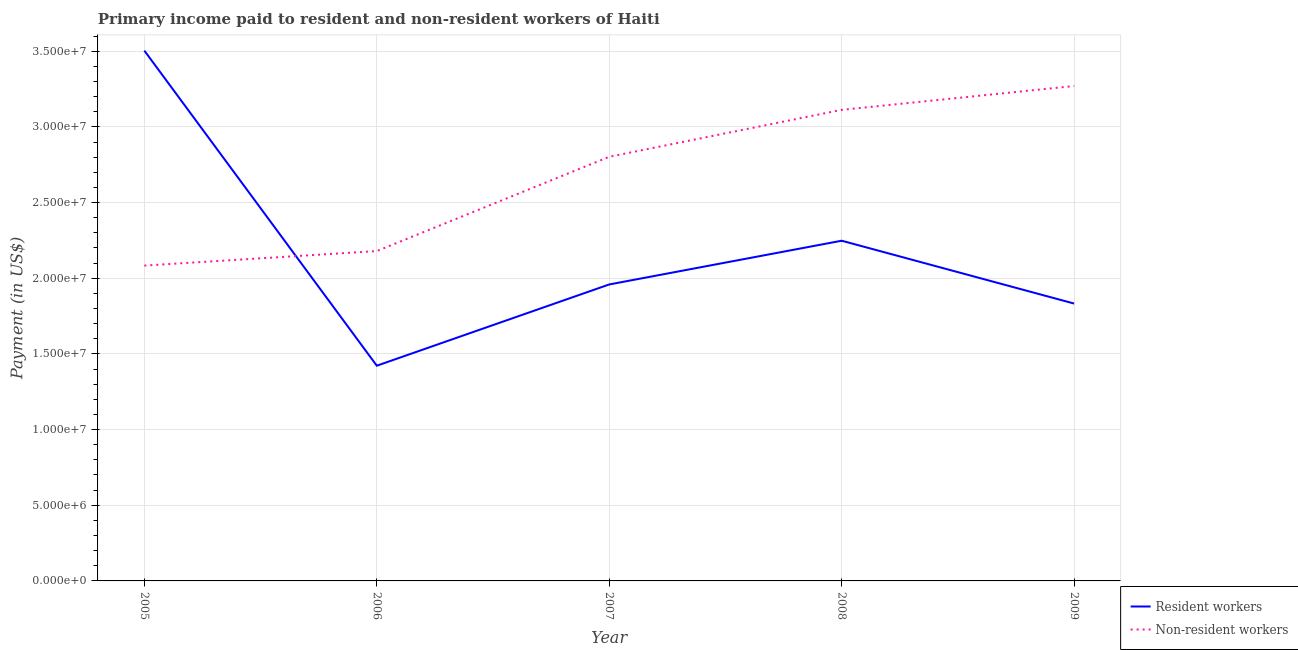Is the number of lines equal to the number of legend labels?
Give a very brief answer. Yes. What is the payment made to resident workers in 2006?
Make the answer very short. 1.42e+07. Across all years, what is the maximum payment made to non-resident workers?
Provide a short and direct response. 3.27e+07. Across all years, what is the minimum payment made to non-resident workers?
Your response must be concise. 2.08e+07. In which year was the payment made to non-resident workers maximum?
Provide a short and direct response. 2009. In which year was the payment made to resident workers minimum?
Make the answer very short. 2006. What is the total payment made to resident workers in the graph?
Make the answer very short. 1.10e+08. What is the difference between the payment made to resident workers in 2007 and that in 2009?
Provide a succinct answer. 1.26e+06. What is the difference between the payment made to resident workers in 2007 and the payment made to non-resident workers in 2006?
Offer a terse response. -2.21e+06. What is the average payment made to non-resident workers per year?
Make the answer very short. 2.69e+07. In the year 2008, what is the difference between the payment made to resident workers and payment made to non-resident workers?
Offer a very short reply. -8.65e+06. In how many years, is the payment made to non-resident workers greater than 24000000 US$?
Provide a short and direct response. 3. What is the ratio of the payment made to resident workers in 2005 to that in 2006?
Provide a succinct answer. 2.46. What is the difference between the highest and the second highest payment made to resident workers?
Make the answer very short. 1.26e+07. What is the difference between the highest and the lowest payment made to resident workers?
Give a very brief answer. 2.08e+07. Is the sum of the payment made to resident workers in 2005 and 2007 greater than the maximum payment made to non-resident workers across all years?
Your answer should be very brief. Yes. Does the payment made to resident workers monotonically increase over the years?
Provide a succinct answer. No. Is the payment made to non-resident workers strictly greater than the payment made to resident workers over the years?
Keep it short and to the point. No. Is the payment made to resident workers strictly less than the payment made to non-resident workers over the years?
Provide a short and direct response. No. What is the difference between two consecutive major ticks on the Y-axis?
Give a very brief answer. 5.00e+06. Are the values on the major ticks of Y-axis written in scientific E-notation?
Your response must be concise. Yes. How many legend labels are there?
Provide a succinct answer. 2. What is the title of the graph?
Make the answer very short. Primary income paid to resident and non-resident workers of Haiti. What is the label or title of the X-axis?
Ensure brevity in your answer.  Year. What is the label or title of the Y-axis?
Make the answer very short. Payment (in US$). What is the Payment (in US$) of Resident workers in 2005?
Your response must be concise. 3.50e+07. What is the Payment (in US$) of Non-resident workers in 2005?
Offer a very short reply. 2.08e+07. What is the Payment (in US$) of Resident workers in 2006?
Your response must be concise. 1.42e+07. What is the Payment (in US$) in Non-resident workers in 2006?
Ensure brevity in your answer.  2.18e+07. What is the Payment (in US$) in Resident workers in 2007?
Your answer should be very brief. 1.96e+07. What is the Payment (in US$) in Non-resident workers in 2007?
Your answer should be very brief. 2.80e+07. What is the Payment (in US$) in Resident workers in 2008?
Your answer should be compact. 2.25e+07. What is the Payment (in US$) in Non-resident workers in 2008?
Keep it short and to the point. 3.11e+07. What is the Payment (in US$) in Resident workers in 2009?
Your answer should be compact. 1.83e+07. What is the Payment (in US$) of Non-resident workers in 2009?
Provide a short and direct response. 3.27e+07. Across all years, what is the maximum Payment (in US$) in Resident workers?
Offer a terse response. 3.50e+07. Across all years, what is the maximum Payment (in US$) in Non-resident workers?
Your response must be concise. 3.27e+07. Across all years, what is the minimum Payment (in US$) in Resident workers?
Offer a very short reply. 1.42e+07. Across all years, what is the minimum Payment (in US$) of Non-resident workers?
Offer a very short reply. 2.08e+07. What is the total Payment (in US$) of Resident workers in the graph?
Provide a short and direct response. 1.10e+08. What is the total Payment (in US$) in Non-resident workers in the graph?
Provide a succinct answer. 1.34e+08. What is the difference between the Payment (in US$) in Resident workers in 2005 and that in 2006?
Provide a short and direct response. 2.08e+07. What is the difference between the Payment (in US$) of Non-resident workers in 2005 and that in 2006?
Provide a succinct answer. -9.59e+05. What is the difference between the Payment (in US$) in Resident workers in 2005 and that in 2007?
Provide a short and direct response. 1.54e+07. What is the difference between the Payment (in US$) in Non-resident workers in 2005 and that in 2007?
Offer a very short reply. -7.19e+06. What is the difference between the Payment (in US$) of Resident workers in 2005 and that in 2008?
Offer a very short reply. 1.26e+07. What is the difference between the Payment (in US$) in Non-resident workers in 2005 and that in 2008?
Your response must be concise. -1.03e+07. What is the difference between the Payment (in US$) of Resident workers in 2005 and that in 2009?
Offer a very short reply. 1.67e+07. What is the difference between the Payment (in US$) of Non-resident workers in 2005 and that in 2009?
Provide a succinct answer. -1.19e+07. What is the difference between the Payment (in US$) in Resident workers in 2006 and that in 2007?
Give a very brief answer. -5.37e+06. What is the difference between the Payment (in US$) in Non-resident workers in 2006 and that in 2007?
Ensure brevity in your answer.  -6.23e+06. What is the difference between the Payment (in US$) in Resident workers in 2006 and that in 2008?
Ensure brevity in your answer.  -8.26e+06. What is the difference between the Payment (in US$) of Non-resident workers in 2006 and that in 2008?
Keep it short and to the point. -9.33e+06. What is the difference between the Payment (in US$) of Resident workers in 2006 and that in 2009?
Offer a terse response. -4.11e+06. What is the difference between the Payment (in US$) of Non-resident workers in 2006 and that in 2009?
Your answer should be compact. -1.09e+07. What is the difference between the Payment (in US$) of Resident workers in 2007 and that in 2008?
Keep it short and to the point. -2.89e+06. What is the difference between the Payment (in US$) of Non-resident workers in 2007 and that in 2008?
Provide a short and direct response. -3.10e+06. What is the difference between the Payment (in US$) in Resident workers in 2007 and that in 2009?
Provide a short and direct response. 1.26e+06. What is the difference between the Payment (in US$) in Non-resident workers in 2007 and that in 2009?
Offer a very short reply. -4.68e+06. What is the difference between the Payment (in US$) of Resident workers in 2008 and that in 2009?
Your answer should be very brief. 4.15e+06. What is the difference between the Payment (in US$) of Non-resident workers in 2008 and that in 2009?
Provide a succinct answer. -1.58e+06. What is the difference between the Payment (in US$) of Resident workers in 2005 and the Payment (in US$) of Non-resident workers in 2006?
Provide a short and direct response. 1.32e+07. What is the difference between the Payment (in US$) in Resident workers in 2005 and the Payment (in US$) in Non-resident workers in 2007?
Make the answer very short. 7.01e+06. What is the difference between the Payment (in US$) of Resident workers in 2005 and the Payment (in US$) of Non-resident workers in 2008?
Provide a succinct answer. 3.91e+06. What is the difference between the Payment (in US$) in Resident workers in 2005 and the Payment (in US$) in Non-resident workers in 2009?
Give a very brief answer. 2.34e+06. What is the difference between the Payment (in US$) in Resident workers in 2006 and the Payment (in US$) in Non-resident workers in 2007?
Your answer should be very brief. -1.38e+07. What is the difference between the Payment (in US$) in Resident workers in 2006 and the Payment (in US$) in Non-resident workers in 2008?
Your response must be concise. -1.69e+07. What is the difference between the Payment (in US$) of Resident workers in 2006 and the Payment (in US$) of Non-resident workers in 2009?
Offer a terse response. -1.85e+07. What is the difference between the Payment (in US$) of Resident workers in 2007 and the Payment (in US$) of Non-resident workers in 2008?
Provide a succinct answer. -1.15e+07. What is the difference between the Payment (in US$) of Resident workers in 2007 and the Payment (in US$) of Non-resident workers in 2009?
Give a very brief answer. -1.31e+07. What is the difference between the Payment (in US$) in Resident workers in 2008 and the Payment (in US$) in Non-resident workers in 2009?
Provide a short and direct response. -1.02e+07. What is the average Payment (in US$) of Resident workers per year?
Offer a very short reply. 2.19e+07. What is the average Payment (in US$) in Non-resident workers per year?
Keep it short and to the point. 2.69e+07. In the year 2005, what is the difference between the Payment (in US$) in Resident workers and Payment (in US$) in Non-resident workers?
Provide a short and direct response. 1.42e+07. In the year 2006, what is the difference between the Payment (in US$) in Resident workers and Payment (in US$) in Non-resident workers?
Your response must be concise. -7.58e+06. In the year 2007, what is the difference between the Payment (in US$) of Resident workers and Payment (in US$) of Non-resident workers?
Provide a succinct answer. -8.44e+06. In the year 2008, what is the difference between the Payment (in US$) of Resident workers and Payment (in US$) of Non-resident workers?
Offer a terse response. -8.65e+06. In the year 2009, what is the difference between the Payment (in US$) of Resident workers and Payment (in US$) of Non-resident workers?
Give a very brief answer. -1.44e+07. What is the ratio of the Payment (in US$) in Resident workers in 2005 to that in 2006?
Give a very brief answer. 2.46. What is the ratio of the Payment (in US$) in Non-resident workers in 2005 to that in 2006?
Give a very brief answer. 0.96. What is the ratio of the Payment (in US$) in Resident workers in 2005 to that in 2007?
Offer a very short reply. 1.79. What is the ratio of the Payment (in US$) in Non-resident workers in 2005 to that in 2007?
Offer a terse response. 0.74. What is the ratio of the Payment (in US$) of Resident workers in 2005 to that in 2008?
Provide a short and direct response. 1.56. What is the ratio of the Payment (in US$) of Non-resident workers in 2005 to that in 2008?
Provide a succinct answer. 0.67. What is the ratio of the Payment (in US$) of Resident workers in 2005 to that in 2009?
Your answer should be compact. 1.91. What is the ratio of the Payment (in US$) of Non-resident workers in 2005 to that in 2009?
Provide a short and direct response. 0.64. What is the ratio of the Payment (in US$) of Resident workers in 2006 to that in 2007?
Your response must be concise. 0.73. What is the ratio of the Payment (in US$) of Non-resident workers in 2006 to that in 2007?
Give a very brief answer. 0.78. What is the ratio of the Payment (in US$) of Resident workers in 2006 to that in 2008?
Make the answer very short. 0.63. What is the ratio of the Payment (in US$) in Non-resident workers in 2006 to that in 2008?
Your answer should be very brief. 0.7. What is the ratio of the Payment (in US$) in Resident workers in 2006 to that in 2009?
Ensure brevity in your answer.  0.78. What is the ratio of the Payment (in US$) in Non-resident workers in 2006 to that in 2009?
Make the answer very short. 0.67. What is the ratio of the Payment (in US$) in Resident workers in 2007 to that in 2008?
Keep it short and to the point. 0.87. What is the ratio of the Payment (in US$) of Non-resident workers in 2007 to that in 2008?
Your response must be concise. 0.9. What is the ratio of the Payment (in US$) of Resident workers in 2007 to that in 2009?
Give a very brief answer. 1.07. What is the ratio of the Payment (in US$) in Non-resident workers in 2007 to that in 2009?
Offer a very short reply. 0.86. What is the ratio of the Payment (in US$) in Resident workers in 2008 to that in 2009?
Your answer should be very brief. 1.23. What is the ratio of the Payment (in US$) in Non-resident workers in 2008 to that in 2009?
Keep it short and to the point. 0.95. What is the difference between the highest and the second highest Payment (in US$) in Resident workers?
Your answer should be very brief. 1.26e+07. What is the difference between the highest and the second highest Payment (in US$) in Non-resident workers?
Keep it short and to the point. 1.58e+06. What is the difference between the highest and the lowest Payment (in US$) in Resident workers?
Make the answer very short. 2.08e+07. What is the difference between the highest and the lowest Payment (in US$) in Non-resident workers?
Keep it short and to the point. 1.19e+07. 